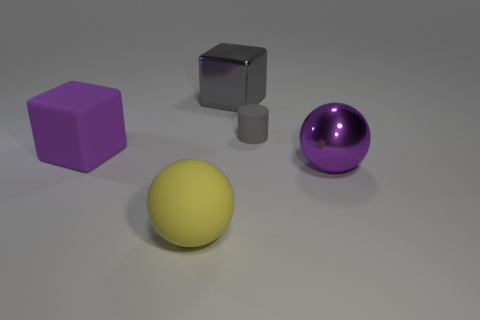There is a shiny object that is the same color as the tiny rubber object; what is its shape?
Give a very brief answer. Cube. How many blue things are matte objects or rubber balls?
Your answer should be compact. 0. The thing that is the same color as the large matte cube is what size?
Ensure brevity in your answer.  Large. There is a tiny gray cylinder; how many balls are left of it?
Provide a succinct answer. 1. There is a thing to the right of the rubber object behind the big matte object behind the large yellow rubber thing; what size is it?
Provide a succinct answer. Large. There is a rubber object in front of the big block to the left of the big yellow matte thing; are there any large yellow matte spheres in front of it?
Give a very brief answer. No. Is the number of gray cubes greater than the number of large brown rubber balls?
Offer a very short reply. Yes. There is a block that is on the left side of the big gray shiny object; what is its color?
Your response must be concise. Purple. Is the number of yellow spheres behind the big yellow matte thing greater than the number of metal objects?
Your answer should be compact. No. Is the large yellow sphere made of the same material as the gray block?
Make the answer very short. No. 